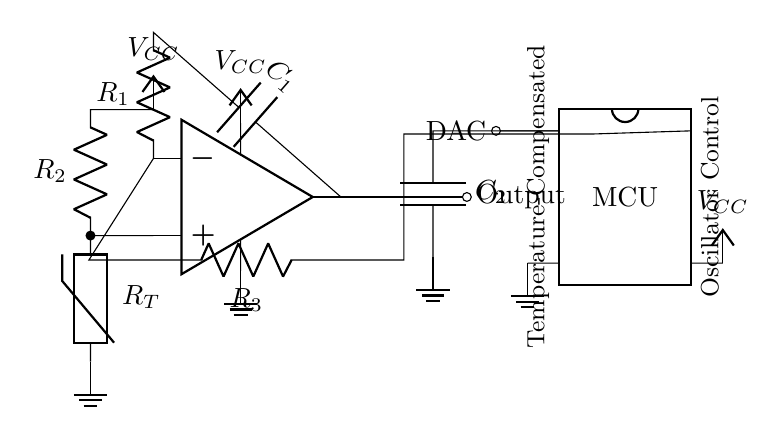What is the main component used for oscillation in this circuit? The main component used for oscillation is the operational amplifier, indicated by the op amp symbol. It generates the oscillating signal necessary for the clock function.
Answer: operational amplifier What is the role of the thermistor in this circuit? The thermistor is used for temperature compensation. It varies its resistance with temperature changes, helping to stabilize the oscillator's frequency by maintaining consistent timing despite environmental temperature variations.
Answer: temperature compensation How many resistors are present in the circuit? By inspecting the circuit diagram, there are three resistors denoted by R1, R2, and R3. Each resistor contributes to different parts of the oscillator function.
Answer: three What is connected to pin 8 of the microcontroller? Pin 8 of the microcontroller is connected to the output of the oscillator, allowing the microcontroller to read the output signal, which can be used for further digital processing or control.
Answer: output What does the capacitor C2 do in this circuit? Capacitor C2 works alongside the microcontroller to filter or smooth the signal, providing stable voltage levels for accurate digital control of the oscillator.
Answer: filter Which component provides the voltage supply for the op amp? The voltage supply for the operational amplifier (op amp) is provided by the DC voltage source labeled VCC, which is connected to the upper pin of the op amp in the diagram.
Answer: VCC 